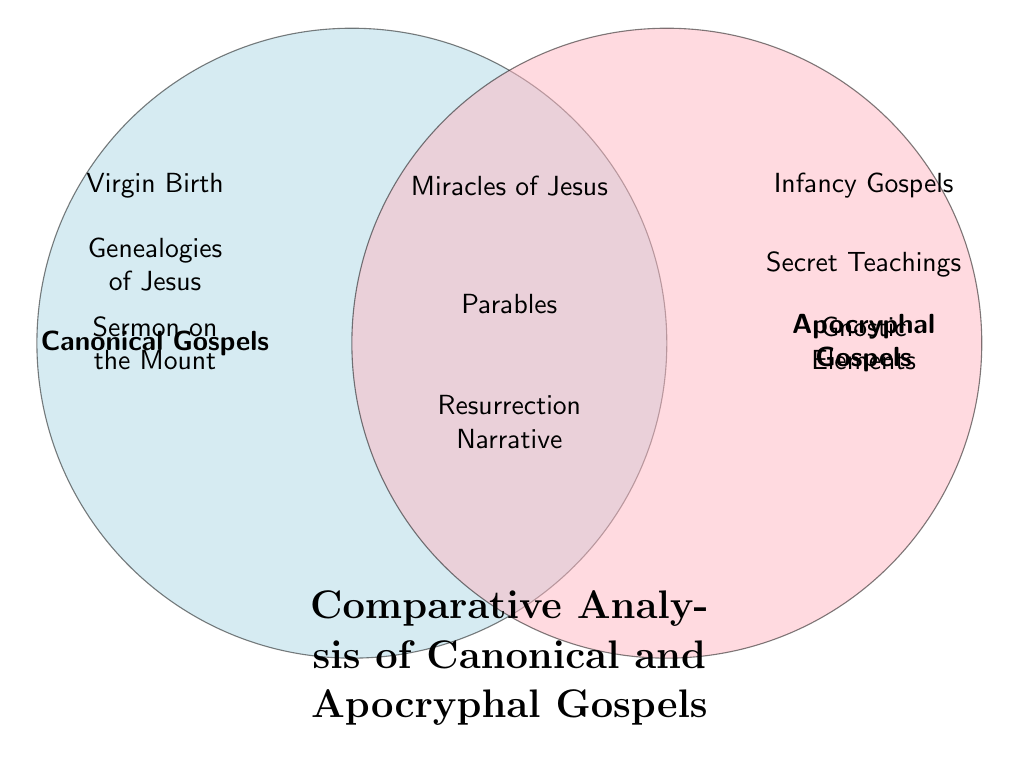What are the themes unique to canonical gospels? The diagram shows the themes unique to canonical gospels listed in the left circle, which are "Virgin Birth," "Genealogies of Jesus," and "Sermon on the Mount."
Answer: Virgin Birth, Genealogies of Jesus, Sermon on the Mount What themes are shared between canonical and apocryphal gospels? By looking at the center area of the Venn diagram, we see it includes "Miracles of Jesus," "Parables," and "Resurrection Narrative," indicating shared themes between both gospels.
Answer: Miracles of Jesus, Parables, Resurrection Narrative How many themes are unique to apocryphal gospels? The unique themes in the right circle of the Venn diagram for apocryphal gospels include "Infancy Gospels," "Secret Teachings," and "Gnostic Elements." Counting these gives a total of three unique themes.
Answer: 3 Which theme appears only in the apocryphal gospels? From the right circle of the diagram, the themes specific to apocryphal gospels are "Infancy Gospels," "Secret Teachings," and "Gnostic Elements." All of these themes are unique to the apocryphal side.
Answer: Infancy Gospels, Secret Teachings, Gnostic Elements What is the total number of themes depicted in the diagram? To find the total, we add the unique themes from canonical gospels (3), the unique themes from apocryphal gospels (3), and the shared themes (3). This totals to 3 + 3 + 3 = 9 themes in total.
Answer: 9 Which unique feature is found in the canonical gospels and not in the apocryphal gospels? The left circle lists features exclusive to canonical gospels, specifically including "Virgin Birth," "Genealogies of Jesus," and "Sermon on the Mount." Thus, any of these can be used to answer the question.
Answer: Virgin Birth, Genealogies of Jesus, Sermon on the Mount What is the main focus of the diagram? The title at the bottom center of the Venn diagram states the focus, which is explicitly "Comparative Analysis of Canonical and Apocryphal Gospels."
Answer: Comparative Analysis of Canonical and Apocryphal Gospels List one theme that is shared between both canonical and apocryphal gospels. The center section of the diagram reveals shared themes such as "Miracles of Jesus," "Parables," and "Resurrection Narrative." Any of these themes can answer the question.
Answer: Miracles of Jesus, Parables, Resurrection Narrative 